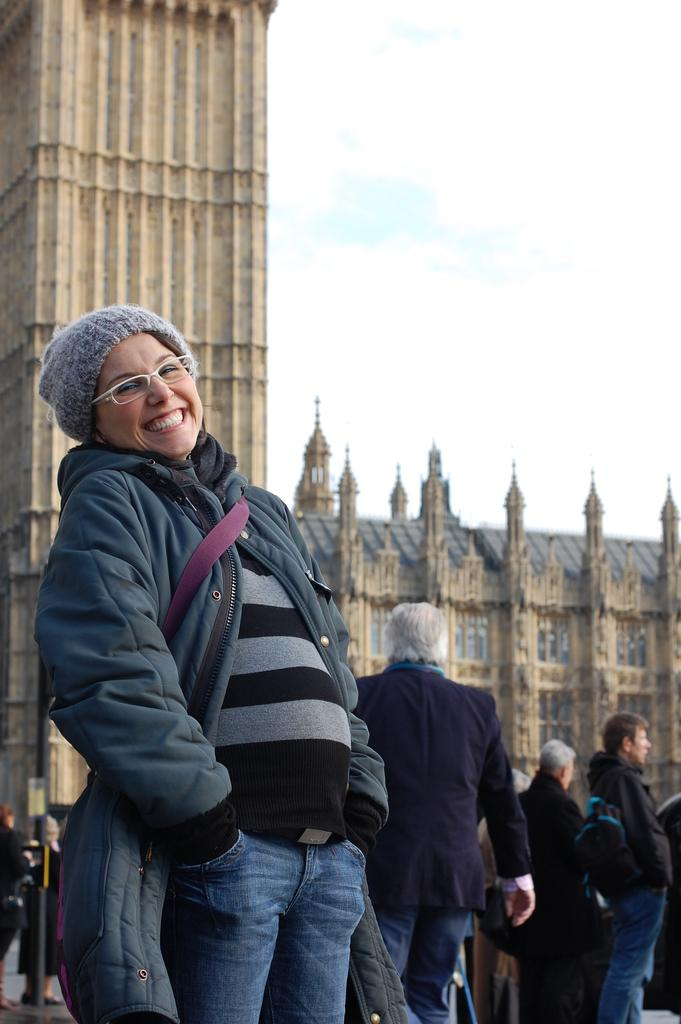What is the main subject of the image? There is a person in the image. What is the person wearing? The person is wearing a sweater, glasses, and a cap. What is the person doing in the image? The person is posing for a photograph. Can you describe the background of the image? There are people and a building in the background, and the sky is visible. What type of fruit is being used as a quiver in the image? There is no fruit or quiver present in the image. 